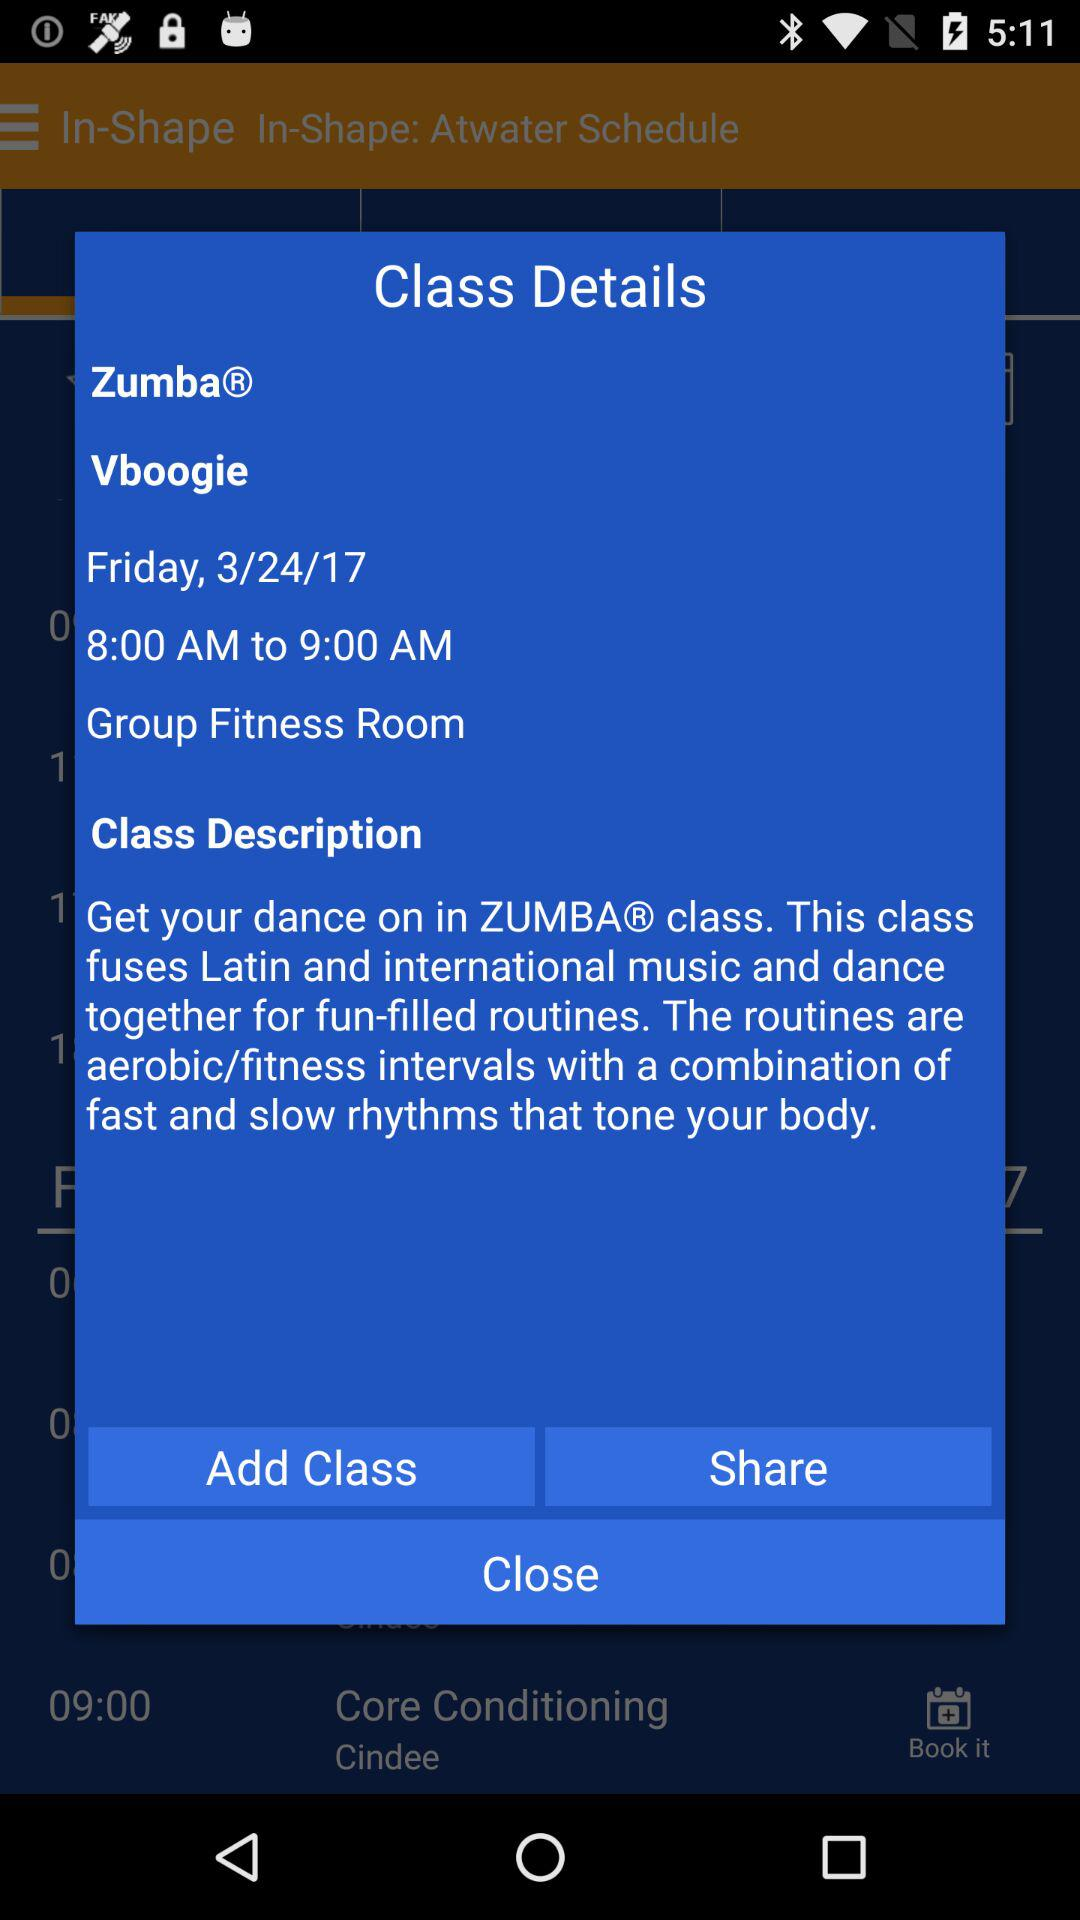What is the application name? The application name is "In-Shape". 